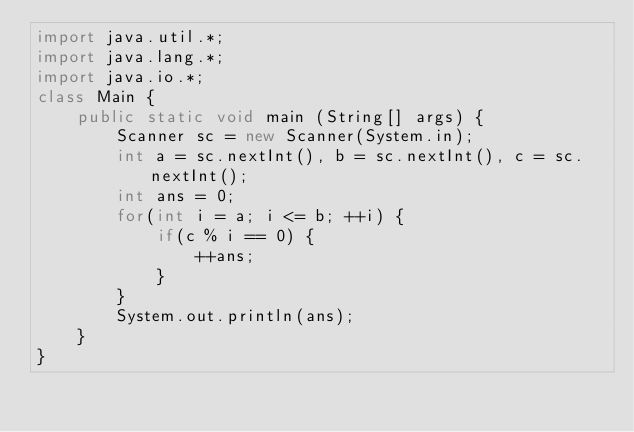Convert code to text. <code><loc_0><loc_0><loc_500><loc_500><_Java_>import java.util.*;
import java.lang.*;
import java.io.*;
class Main {
	public static void main (String[] args) {
		Scanner sc = new Scanner(System.in);
		int a = sc.nextInt(), b = sc.nextInt(), c = sc.nextInt();
		int ans = 0;
		for(int i = a; i <= b; ++i) {
			if(c % i == 0) {
				++ans;
			}
		}
		System.out.println(ans);
	}
}
</code> 